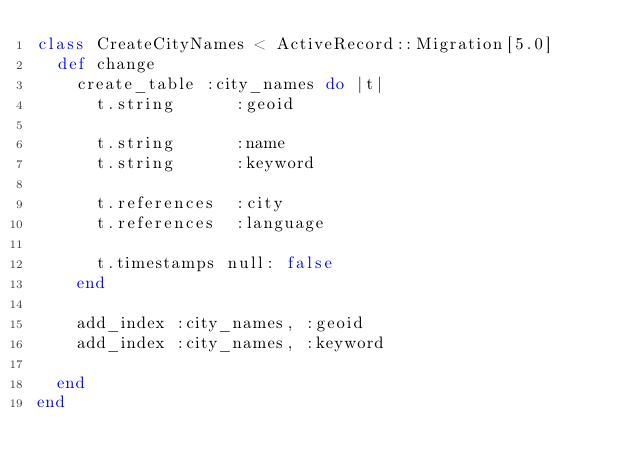Convert code to text. <code><loc_0><loc_0><loc_500><loc_500><_Ruby_>class CreateCityNames < ActiveRecord::Migration[5.0]
  def change
    create_table :city_names do |t|
      t.string      :geoid

      t.string      :name
      t.string      :keyword

      t.references  :city
      t.references  :language

      t.timestamps null: false
    end

    add_index :city_names, :geoid
    add_index :city_names, :keyword

  end
end
</code> 